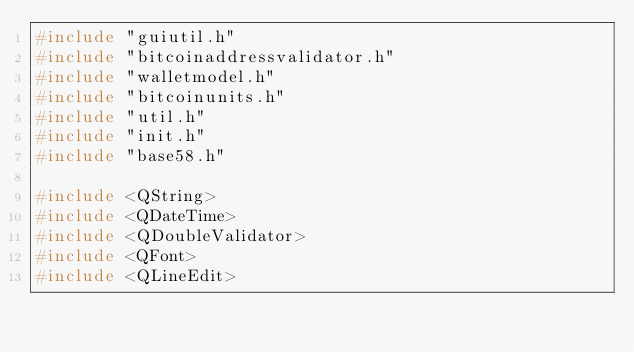Convert code to text. <code><loc_0><loc_0><loc_500><loc_500><_C++_>#include "guiutil.h"
#include "bitcoinaddressvalidator.h"
#include "walletmodel.h"
#include "bitcoinunits.h"
#include "util.h"
#include "init.h"
#include "base58.h"

#include <QString>
#include <QDateTime>
#include <QDoubleValidator>
#include <QFont>
#include <QLineEdit></code> 